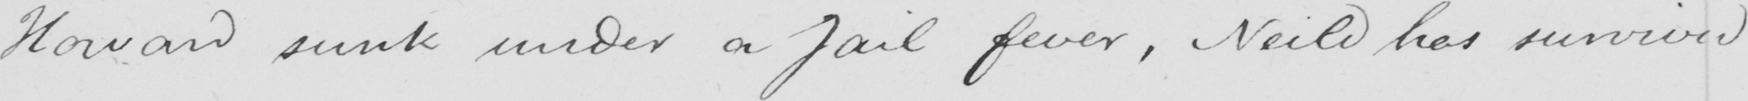What text is written in this handwritten line? Howard sunk under a jail fever , Neild has survived 